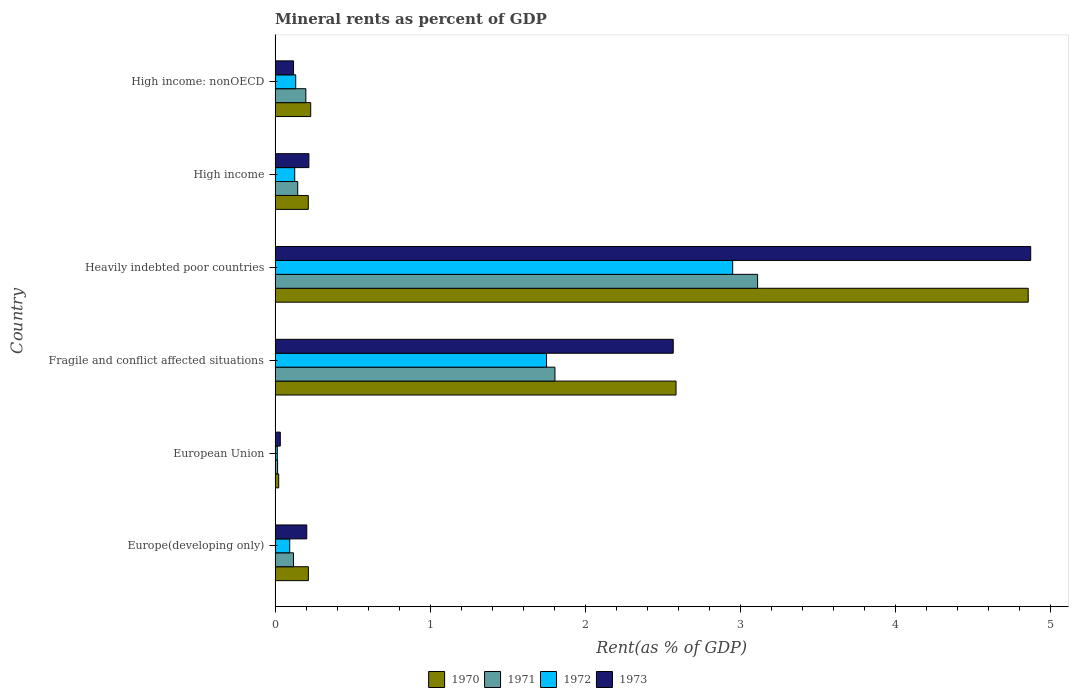How many different coloured bars are there?
Keep it short and to the point. 4. How many groups of bars are there?
Your answer should be compact. 6. Are the number of bars per tick equal to the number of legend labels?
Your response must be concise. Yes. How many bars are there on the 3rd tick from the bottom?
Make the answer very short. 4. What is the label of the 2nd group of bars from the top?
Your answer should be compact. High income. In how many cases, is the number of bars for a given country not equal to the number of legend labels?
Make the answer very short. 0. What is the mineral rent in 1972 in Europe(developing only)?
Your answer should be compact. 0.09. Across all countries, what is the maximum mineral rent in 1972?
Keep it short and to the point. 2.95. Across all countries, what is the minimum mineral rent in 1973?
Provide a succinct answer. 0.03. In which country was the mineral rent in 1972 maximum?
Ensure brevity in your answer.  Heavily indebted poor countries. What is the total mineral rent in 1972 in the graph?
Provide a short and direct response. 5.07. What is the difference between the mineral rent in 1971 in Europe(developing only) and that in Fragile and conflict affected situations?
Your answer should be very brief. -1.69. What is the difference between the mineral rent in 1970 in High income and the mineral rent in 1973 in High income: nonOECD?
Provide a short and direct response. 0.1. What is the average mineral rent in 1971 per country?
Your answer should be very brief. 0.9. What is the difference between the mineral rent in 1973 and mineral rent in 1971 in Heavily indebted poor countries?
Provide a short and direct response. 1.76. What is the ratio of the mineral rent in 1973 in Europe(developing only) to that in European Union?
Offer a terse response. 6.06. What is the difference between the highest and the second highest mineral rent in 1970?
Your answer should be compact. 2.27. What is the difference between the highest and the lowest mineral rent in 1972?
Offer a very short reply. 2.94. Is it the case that in every country, the sum of the mineral rent in 1971 and mineral rent in 1970 is greater than the sum of mineral rent in 1973 and mineral rent in 1972?
Ensure brevity in your answer.  No. How many countries are there in the graph?
Keep it short and to the point. 6. What is the difference between two consecutive major ticks on the X-axis?
Your answer should be very brief. 1. Are the values on the major ticks of X-axis written in scientific E-notation?
Offer a terse response. No. How many legend labels are there?
Keep it short and to the point. 4. What is the title of the graph?
Give a very brief answer. Mineral rents as percent of GDP. What is the label or title of the X-axis?
Keep it short and to the point. Rent(as % of GDP). What is the Rent(as % of GDP) of 1970 in Europe(developing only)?
Provide a short and direct response. 0.21. What is the Rent(as % of GDP) in 1971 in Europe(developing only)?
Your response must be concise. 0.12. What is the Rent(as % of GDP) in 1972 in Europe(developing only)?
Keep it short and to the point. 0.09. What is the Rent(as % of GDP) of 1973 in Europe(developing only)?
Your response must be concise. 0.2. What is the Rent(as % of GDP) in 1970 in European Union?
Your answer should be compact. 0.02. What is the Rent(as % of GDP) in 1971 in European Union?
Your response must be concise. 0.02. What is the Rent(as % of GDP) in 1972 in European Union?
Ensure brevity in your answer.  0.01. What is the Rent(as % of GDP) in 1973 in European Union?
Your answer should be very brief. 0.03. What is the Rent(as % of GDP) of 1970 in Fragile and conflict affected situations?
Your answer should be compact. 2.59. What is the Rent(as % of GDP) in 1971 in Fragile and conflict affected situations?
Keep it short and to the point. 1.81. What is the Rent(as % of GDP) in 1972 in Fragile and conflict affected situations?
Your response must be concise. 1.75. What is the Rent(as % of GDP) in 1973 in Fragile and conflict affected situations?
Ensure brevity in your answer.  2.57. What is the Rent(as % of GDP) of 1970 in Heavily indebted poor countries?
Offer a very short reply. 4.86. What is the Rent(as % of GDP) in 1971 in Heavily indebted poor countries?
Make the answer very short. 3.11. What is the Rent(as % of GDP) in 1972 in Heavily indebted poor countries?
Keep it short and to the point. 2.95. What is the Rent(as % of GDP) in 1973 in Heavily indebted poor countries?
Keep it short and to the point. 4.87. What is the Rent(as % of GDP) of 1970 in High income?
Make the answer very short. 0.21. What is the Rent(as % of GDP) of 1971 in High income?
Offer a terse response. 0.15. What is the Rent(as % of GDP) in 1972 in High income?
Your response must be concise. 0.13. What is the Rent(as % of GDP) in 1973 in High income?
Offer a terse response. 0.22. What is the Rent(as % of GDP) in 1970 in High income: nonOECD?
Provide a short and direct response. 0.23. What is the Rent(as % of GDP) of 1971 in High income: nonOECD?
Provide a succinct answer. 0.2. What is the Rent(as % of GDP) of 1972 in High income: nonOECD?
Your response must be concise. 0.13. What is the Rent(as % of GDP) in 1973 in High income: nonOECD?
Offer a very short reply. 0.12. Across all countries, what is the maximum Rent(as % of GDP) of 1970?
Offer a terse response. 4.86. Across all countries, what is the maximum Rent(as % of GDP) of 1971?
Give a very brief answer. 3.11. Across all countries, what is the maximum Rent(as % of GDP) in 1972?
Make the answer very short. 2.95. Across all countries, what is the maximum Rent(as % of GDP) of 1973?
Provide a short and direct response. 4.87. Across all countries, what is the minimum Rent(as % of GDP) of 1970?
Offer a very short reply. 0.02. Across all countries, what is the minimum Rent(as % of GDP) in 1971?
Your answer should be compact. 0.02. Across all countries, what is the minimum Rent(as % of GDP) in 1972?
Offer a very short reply. 0.01. Across all countries, what is the minimum Rent(as % of GDP) of 1973?
Ensure brevity in your answer.  0.03. What is the total Rent(as % of GDP) of 1970 in the graph?
Provide a short and direct response. 8.13. What is the total Rent(as % of GDP) in 1971 in the graph?
Provide a short and direct response. 5.4. What is the total Rent(as % of GDP) in 1972 in the graph?
Your response must be concise. 5.07. What is the total Rent(as % of GDP) in 1973 in the graph?
Your response must be concise. 8.02. What is the difference between the Rent(as % of GDP) of 1970 in Europe(developing only) and that in European Union?
Offer a very short reply. 0.19. What is the difference between the Rent(as % of GDP) in 1971 in Europe(developing only) and that in European Union?
Provide a succinct answer. 0.1. What is the difference between the Rent(as % of GDP) of 1972 in Europe(developing only) and that in European Union?
Your answer should be very brief. 0.08. What is the difference between the Rent(as % of GDP) of 1973 in Europe(developing only) and that in European Union?
Offer a very short reply. 0.17. What is the difference between the Rent(as % of GDP) in 1970 in Europe(developing only) and that in Fragile and conflict affected situations?
Make the answer very short. -2.37. What is the difference between the Rent(as % of GDP) of 1971 in Europe(developing only) and that in Fragile and conflict affected situations?
Your answer should be compact. -1.69. What is the difference between the Rent(as % of GDP) of 1972 in Europe(developing only) and that in Fragile and conflict affected situations?
Make the answer very short. -1.66. What is the difference between the Rent(as % of GDP) in 1973 in Europe(developing only) and that in Fragile and conflict affected situations?
Offer a terse response. -2.36. What is the difference between the Rent(as % of GDP) in 1970 in Europe(developing only) and that in Heavily indebted poor countries?
Your response must be concise. -4.64. What is the difference between the Rent(as % of GDP) in 1971 in Europe(developing only) and that in Heavily indebted poor countries?
Offer a very short reply. -2.99. What is the difference between the Rent(as % of GDP) of 1972 in Europe(developing only) and that in Heavily indebted poor countries?
Make the answer very short. -2.86. What is the difference between the Rent(as % of GDP) of 1973 in Europe(developing only) and that in Heavily indebted poor countries?
Provide a succinct answer. -4.67. What is the difference between the Rent(as % of GDP) in 1970 in Europe(developing only) and that in High income?
Your answer should be very brief. 0. What is the difference between the Rent(as % of GDP) in 1971 in Europe(developing only) and that in High income?
Offer a very short reply. -0.03. What is the difference between the Rent(as % of GDP) in 1972 in Europe(developing only) and that in High income?
Your answer should be compact. -0.03. What is the difference between the Rent(as % of GDP) of 1973 in Europe(developing only) and that in High income?
Your answer should be very brief. -0.01. What is the difference between the Rent(as % of GDP) in 1970 in Europe(developing only) and that in High income: nonOECD?
Ensure brevity in your answer.  -0.01. What is the difference between the Rent(as % of GDP) of 1971 in Europe(developing only) and that in High income: nonOECD?
Keep it short and to the point. -0.08. What is the difference between the Rent(as % of GDP) of 1972 in Europe(developing only) and that in High income: nonOECD?
Offer a very short reply. -0.04. What is the difference between the Rent(as % of GDP) of 1973 in Europe(developing only) and that in High income: nonOECD?
Your answer should be very brief. 0.09. What is the difference between the Rent(as % of GDP) of 1970 in European Union and that in Fragile and conflict affected situations?
Your response must be concise. -2.56. What is the difference between the Rent(as % of GDP) in 1971 in European Union and that in Fragile and conflict affected situations?
Your response must be concise. -1.79. What is the difference between the Rent(as % of GDP) in 1972 in European Union and that in Fragile and conflict affected situations?
Ensure brevity in your answer.  -1.74. What is the difference between the Rent(as % of GDP) in 1973 in European Union and that in Fragile and conflict affected situations?
Your response must be concise. -2.53. What is the difference between the Rent(as % of GDP) of 1970 in European Union and that in Heavily indebted poor countries?
Provide a short and direct response. -4.83. What is the difference between the Rent(as % of GDP) in 1971 in European Union and that in Heavily indebted poor countries?
Your answer should be very brief. -3.1. What is the difference between the Rent(as % of GDP) in 1972 in European Union and that in Heavily indebted poor countries?
Your answer should be very brief. -2.94. What is the difference between the Rent(as % of GDP) of 1973 in European Union and that in Heavily indebted poor countries?
Offer a terse response. -4.84. What is the difference between the Rent(as % of GDP) in 1970 in European Union and that in High income?
Your response must be concise. -0.19. What is the difference between the Rent(as % of GDP) in 1971 in European Union and that in High income?
Make the answer very short. -0.13. What is the difference between the Rent(as % of GDP) of 1972 in European Union and that in High income?
Provide a succinct answer. -0.11. What is the difference between the Rent(as % of GDP) of 1973 in European Union and that in High income?
Provide a succinct answer. -0.18. What is the difference between the Rent(as % of GDP) in 1970 in European Union and that in High income: nonOECD?
Make the answer very short. -0.21. What is the difference between the Rent(as % of GDP) of 1971 in European Union and that in High income: nonOECD?
Your answer should be compact. -0.18. What is the difference between the Rent(as % of GDP) in 1972 in European Union and that in High income: nonOECD?
Your answer should be very brief. -0.12. What is the difference between the Rent(as % of GDP) in 1973 in European Union and that in High income: nonOECD?
Your answer should be compact. -0.09. What is the difference between the Rent(as % of GDP) in 1970 in Fragile and conflict affected situations and that in Heavily indebted poor countries?
Give a very brief answer. -2.27. What is the difference between the Rent(as % of GDP) in 1971 in Fragile and conflict affected situations and that in Heavily indebted poor countries?
Provide a short and direct response. -1.31. What is the difference between the Rent(as % of GDP) of 1972 in Fragile and conflict affected situations and that in Heavily indebted poor countries?
Offer a terse response. -1.2. What is the difference between the Rent(as % of GDP) in 1973 in Fragile and conflict affected situations and that in Heavily indebted poor countries?
Your answer should be very brief. -2.31. What is the difference between the Rent(as % of GDP) of 1970 in Fragile and conflict affected situations and that in High income?
Provide a succinct answer. 2.37. What is the difference between the Rent(as % of GDP) of 1971 in Fragile and conflict affected situations and that in High income?
Offer a terse response. 1.66. What is the difference between the Rent(as % of GDP) in 1972 in Fragile and conflict affected situations and that in High income?
Offer a very short reply. 1.62. What is the difference between the Rent(as % of GDP) in 1973 in Fragile and conflict affected situations and that in High income?
Offer a terse response. 2.35. What is the difference between the Rent(as % of GDP) in 1970 in Fragile and conflict affected situations and that in High income: nonOECD?
Give a very brief answer. 2.36. What is the difference between the Rent(as % of GDP) in 1971 in Fragile and conflict affected situations and that in High income: nonOECD?
Your answer should be very brief. 1.61. What is the difference between the Rent(as % of GDP) of 1972 in Fragile and conflict affected situations and that in High income: nonOECD?
Provide a succinct answer. 1.62. What is the difference between the Rent(as % of GDP) in 1973 in Fragile and conflict affected situations and that in High income: nonOECD?
Ensure brevity in your answer.  2.45. What is the difference between the Rent(as % of GDP) in 1970 in Heavily indebted poor countries and that in High income?
Keep it short and to the point. 4.64. What is the difference between the Rent(as % of GDP) in 1971 in Heavily indebted poor countries and that in High income?
Make the answer very short. 2.97. What is the difference between the Rent(as % of GDP) in 1972 in Heavily indebted poor countries and that in High income?
Provide a short and direct response. 2.82. What is the difference between the Rent(as % of GDP) of 1973 in Heavily indebted poor countries and that in High income?
Offer a terse response. 4.66. What is the difference between the Rent(as % of GDP) of 1970 in Heavily indebted poor countries and that in High income: nonOECD?
Your response must be concise. 4.63. What is the difference between the Rent(as % of GDP) of 1971 in Heavily indebted poor countries and that in High income: nonOECD?
Give a very brief answer. 2.91. What is the difference between the Rent(as % of GDP) of 1972 in Heavily indebted poor countries and that in High income: nonOECD?
Give a very brief answer. 2.82. What is the difference between the Rent(as % of GDP) of 1973 in Heavily indebted poor countries and that in High income: nonOECD?
Offer a terse response. 4.75. What is the difference between the Rent(as % of GDP) in 1970 in High income and that in High income: nonOECD?
Your response must be concise. -0.02. What is the difference between the Rent(as % of GDP) of 1971 in High income and that in High income: nonOECD?
Keep it short and to the point. -0.05. What is the difference between the Rent(as % of GDP) of 1972 in High income and that in High income: nonOECD?
Your response must be concise. -0.01. What is the difference between the Rent(as % of GDP) in 1973 in High income and that in High income: nonOECD?
Offer a very short reply. 0.1. What is the difference between the Rent(as % of GDP) of 1970 in Europe(developing only) and the Rent(as % of GDP) of 1971 in European Union?
Provide a short and direct response. 0.2. What is the difference between the Rent(as % of GDP) in 1970 in Europe(developing only) and the Rent(as % of GDP) in 1972 in European Union?
Offer a very short reply. 0.2. What is the difference between the Rent(as % of GDP) in 1970 in Europe(developing only) and the Rent(as % of GDP) in 1973 in European Union?
Your answer should be compact. 0.18. What is the difference between the Rent(as % of GDP) of 1971 in Europe(developing only) and the Rent(as % of GDP) of 1972 in European Union?
Offer a very short reply. 0.1. What is the difference between the Rent(as % of GDP) of 1971 in Europe(developing only) and the Rent(as % of GDP) of 1973 in European Union?
Give a very brief answer. 0.09. What is the difference between the Rent(as % of GDP) of 1972 in Europe(developing only) and the Rent(as % of GDP) of 1973 in European Union?
Your answer should be compact. 0.06. What is the difference between the Rent(as % of GDP) of 1970 in Europe(developing only) and the Rent(as % of GDP) of 1971 in Fragile and conflict affected situations?
Offer a very short reply. -1.59. What is the difference between the Rent(as % of GDP) in 1970 in Europe(developing only) and the Rent(as % of GDP) in 1972 in Fragile and conflict affected situations?
Your answer should be very brief. -1.54. What is the difference between the Rent(as % of GDP) in 1970 in Europe(developing only) and the Rent(as % of GDP) in 1973 in Fragile and conflict affected situations?
Your answer should be very brief. -2.35. What is the difference between the Rent(as % of GDP) of 1971 in Europe(developing only) and the Rent(as % of GDP) of 1972 in Fragile and conflict affected situations?
Offer a very short reply. -1.63. What is the difference between the Rent(as % of GDP) of 1971 in Europe(developing only) and the Rent(as % of GDP) of 1973 in Fragile and conflict affected situations?
Give a very brief answer. -2.45. What is the difference between the Rent(as % of GDP) of 1972 in Europe(developing only) and the Rent(as % of GDP) of 1973 in Fragile and conflict affected situations?
Keep it short and to the point. -2.47. What is the difference between the Rent(as % of GDP) of 1970 in Europe(developing only) and the Rent(as % of GDP) of 1971 in Heavily indebted poor countries?
Provide a short and direct response. -2.9. What is the difference between the Rent(as % of GDP) in 1970 in Europe(developing only) and the Rent(as % of GDP) in 1972 in Heavily indebted poor countries?
Provide a succinct answer. -2.74. What is the difference between the Rent(as % of GDP) in 1970 in Europe(developing only) and the Rent(as % of GDP) in 1973 in Heavily indebted poor countries?
Give a very brief answer. -4.66. What is the difference between the Rent(as % of GDP) of 1971 in Europe(developing only) and the Rent(as % of GDP) of 1972 in Heavily indebted poor countries?
Your answer should be very brief. -2.83. What is the difference between the Rent(as % of GDP) in 1971 in Europe(developing only) and the Rent(as % of GDP) in 1973 in Heavily indebted poor countries?
Your response must be concise. -4.76. What is the difference between the Rent(as % of GDP) of 1972 in Europe(developing only) and the Rent(as % of GDP) of 1973 in Heavily indebted poor countries?
Give a very brief answer. -4.78. What is the difference between the Rent(as % of GDP) of 1970 in Europe(developing only) and the Rent(as % of GDP) of 1971 in High income?
Provide a short and direct response. 0.07. What is the difference between the Rent(as % of GDP) of 1970 in Europe(developing only) and the Rent(as % of GDP) of 1972 in High income?
Your answer should be compact. 0.09. What is the difference between the Rent(as % of GDP) in 1970 in Europe(developing only) and the Rent(as % of GDP) in 1973 in High income?
Your answer should be very brief. -0. What is the difference between the Rent(as % of GDP) of 1971 in Europe(developing only) and the Rent(as % of GDP) of 1972 in High income?
Offer a terse response. -0.01. What is the difference between the Rent(as % of GDP) of 1971 in Europe(developing only) and the Rent(as % of GDP) of 1973 in High income?
Offer a terse response. -0.1. What is the difference between the Rent(as % of GDP) of 1972 in Europe(developing only) and the Rent(as % of GDP) of 1973 in High income?
Offer a very short reply. -0.12. What is the difference between the Rent(as % of GDP) of 1970 in Europe(developing only) and the Rent(as % of GDP) of 1971 in High income: nonOECD?
Make the answer very short. 0.02. What is the difference between the Rent(as % of GDP) in 1970 in Europe(developing only) and the Rent(as % of GDP) in 1972 in High income: nonOECD?
Provide a short and direct response. 0.08. What is the difference between the Rent(as % of GDP) of 1970 in Europe(developing only) and the Rent(as % of GDP) of 1973 in High income: nonOECD?
Your response must be concise. 0.1. What is the difference between the Rent(as % of GDP) in 1971 in Europe(developing only) and the Rent(as % of GDP) in 1972 in High income: nonOECD?
Offer a very short reply. -0.01. What is the difference between the Rent(as % of GDP) of 1971 in Europe(developing only) and the Rent(as % of GDP) of 1973 in High income: nonOECD?
Ensure brevity in your answer.  -0. What is the difference between the Rent(as % of GDP) of 1972 in Europe(developing only) and the Rent(as % of GDP) of 1973 in High income: nonOECD?
Make the answer very short. -0.02. What is the difference between the Rent(as % of GDP) of 1970 in European Union and the Rent(as % of GDP) of 1971 in Fragile and conflict affected situations?
Your answer should be very brief. -1.78. What is the difference between the Rent(as % of GDP) of 1970 in European Union and the Rent(as % of GDP) of 1972 in Fragile and conflict affected situations?
Your answer should be very brief. -1.73. What is the difference between the Rent(as % of GDP) of 1970 in European Union and the Rent(as % of GDP) of 1973 in Fragile and conflict affected situations?
Ensure brevity in your answer.  -2.54. What is the difference between the Rent(as % of GDP) of 1971 in European Union and the Rent(as % of GDP) of 1972 in Fragile and conflict affected situations?
Make the answer very short. -1.73. What is the difference between the Rent(as % of GDP) of 1971 in European Union and the Rent(as % of GDP) of 1973 in Fragile and conflict affected situations?
Ensure brevity in your answer.  -2.55. What is the difference between the Rent(as % of GDP) of 1972 in European Union and the Rent(as % of GDP) of 1973 in Fragile and conflict affected situations?
Keep it short and to the point. -2.55. What is the difference between the Rent(as % of GDP) in 1970 in European Union and the Rent(as % of GDP) in 1971 in Heavily indebted poor countries?
Offer a terse response. -3.09. What is the difference between the Rent(as % of GDP) in 1970 in European Union and the Rent(as % of GDP) in 1972 in Heavily indebted poor countries?
Provide a succinct answer. -2.93. What is the difference between the Rent(as % of GDP) in 1970 in European Union and the Rent(as % of GDP) in 1973 in Heavily indebted poor countries?
Your answer should be compact. -4.85. What is the difference between the Rent(as % of GDP) in 1971 in European Union and the Rent(as % of GDP) in 1972 in Heavily indebted poor countries?
Your answer should be very brief. -2.94. What is the difference between the Rent(as % of GDP) of 1971 in European Union and the Rent(as % of GDP) of 1973 in Heavily indebted poor countries?
Your answer should be very brief. -4.86. What is the difference between the Rent(as % of GDP) in 1972 in European Union and the Rent(as % of GDP) in 1973 in Heavily indebted poor countries?
Make the answer very short. -4.86. What is the difference between the Rent(as % of GDP) of 1970 in European Union and the Rent(as % of GDP) of 1971 in High income?
Provide a short and direct response. -0.12. What is the difference between the Rent(as % of GDP) of 1970 in European Union and the Rent(as % of GDP) of 1972 in High income?
Your response must be concise. -0.1. What is the difference between the Rent(as % of GDP) of 1970 in European Union and the Rent(as % of GDP) of 1973 in High income?
Keep it short and to the point. -0.19. What is the difference between the Rent(as % of GDP) of 1971 in European Union and the Rent(as % of GDP) of 1972 in High income?
Ensure brevity in your answer.  -0.11. What is the difference between the Rent(as % of GDP) of 1971 in European Union and the Rent(as % of GDP) of 1973 in High income?
Your response must be concise. -0.2. What is the difference between the Rent(as % of GDP) of 1972 in European Union and the Rent(as % of GDP) of 1973 in High income?
Your answer should be very brief. -0.2. What is the difference between the Rent(as % of GDP) in 1970 in European Union and the Rent(as % of GDP) in 1971 in High income: nonOECD?
Make the answer very short. -0.18. What is the difference between the Rent(as % of GDP) in 1970 in European Union and the Rent(as % of GDP) in 1972 in High income: nonOECD?
Your answer should be very brief. -0.11. What is the difference between the Rent(as % of GDP) in 1970 in European Union and the Rent(as % of GDP) in 1973 in High income: nonOECD?
Your answer should be compact. -0.1. What is the difference between the Rent(as % of GDP) in 1971 in European Union and the Rent(as % of GDP) in 1972 in High income: nonOECD?
Offer a terse response. -0.12. What is the difference between the Rent(as % of GDP) in 1971 in European Union and the Rent(as % of GDP) in 1973 in High income: nonOECD?
Offer a terse response. -0.1. What is the difference between the Rent(as % of GDP) in 1972 in European Union and the Rent(as % of GDP) in 1973 in High income: nonOECD?
Your answer should be compact. -0.1. What is the difference between the Rent(as % of GDP) in 1970 in Fragile and conflict affected situations and the Rent(as % of GDP) in 1971 in Heavily indebted poor countries?
Give a very brief answer. -0.53. What is the difference between the Rent(as % of GDP) of 1970 in Fragile and conflict affected situations and the Rent(as % of GDP) of 1972 in Heavily indebted poor countries?
Provide a short and direct response. -0.37. What is the difference between the Rent(as % of GDP) of 1970 in Fragile and conflict affected situations and the Rent(as % of GDP) of 1973 in Heavily indebted poor countries?
Provide a short and direct response. -2.29. What is the difference between the Rent(as % of GDP) of 1971 in Fragile and conflict affected situations and the Rent(as % of GDP) of 1972 in Heavily indebted poor countries?
Keep it short and to the point. -1.15. What is the difference between the Rent(as % of GDP) in 1971 in Fragile and conflict affected situations and the Rent(as % of GDP) in 1973 in Heavily indebted poor countries?
Provide a short and direct response. -3.07. What is the difference between the Rent(as % of GDP) in 1972 in Fragile and conflict affected situations and the Rent(as % of GDP) in 1973 in Heavily indebted poor countries?
Make the answer very short. -3.12. What is the difference between the Rent(as % of GDP) of 1970 in Fragile and conflict affected situations and the Rent(as % of GDP) of 1971 in High income?
Your response must be concise. 2.44. What is the difference between the Rent(as % of GDP) of 1970 in Fragile and conflict affected situations and the Rent(as % of GDP) of 1972 in High income?
Offer a terse response. 2.46. What is the difference between the Rent(as % of GDP) of 1970 in Fragile and conflict affected situations and the Rent(as % of GDP) of 1973 in High income?
Offer a terse response. 2.37. What is the difference between the Rent(as % of GDP) in 1971 in Fragile and conflict affected situations and the Rent(as % of GDP) in 1972 in High income?
Your response must be concise. 1.68. What is the difference between the Rent(as % of GDP) of 1971 in Fragile and conflict affected situations and the Rent(as % of GDP) of 1973 in High income?
Your response must be concise. 1.59. What is the difference between the Rent(as % of GDP) of 1972 in Fragile and conflict affected situations and the Rent(as % of GDP) of 1973 in High income?
Make the answer very short. 1.53. What is the difference between the Rent(as % of GDP) in 1970 in Fragile and conflict affected situations and the Rent(as % of GDP) in 1971 in High income: nonOECD?
Keep it short and to the point. 2.39. What is the difference between the Rent(as % of GDP) in 1970 in Fragile and conflict affected situations and the Rent(as % of GDP) in 1972 in High income: nonOECD?
Offer a terse response. 2.45. What is the difference between the Rent(as % of GDP) of 1970 in Fragile and conflict affected situations and the Rent(as % of GDP) of 1973 in High income: nonOECD?
Your answer should be compact. 2.47. What is the difference between the Rent(as % of GDP) of 1971 in Fragile and conflict affected situations and the Rent(as % of GDP) of 1972 in High income: nonOECD?
Make the answer very short. 1.67. What is the difference between the Rent(as % of GDP) of 1971 in Fragile and conflict affected situations and the Rent(as % of GDP) of 1973 in High income: nonOECD?
Offer a very short reply. 1.69. What is the difference between the Rent(as % of GDP) in 1972 in Fragile and conflict affected situations and the Rent(as % of GDP) in 1973 in High income: nonOECD?
Offer a very short reply. 1.63. What is the difference between the Rent(as % of GDP) of 1970 in Heavily indebted poor countries and the Rent(as % of GDP) of 1971 in High income?
Give a very brief answer. 4.71. What is the difference between the Rent(as % of GDP) of 1970 in Heavily indebted poor countries and the Rent(as % of GDP) of 1972 in High income?
Provide a succinct answer. 4.73. What is the difference between the Rent(as % of GDP) of 1970 in Heavily indebted poor countries and the Rent(as % of GDP) of 1973 in High income?
Ensure brevity in your answer.  4.64. What is the difference between the Rent(as % of GDP) of 1971 in Heavily indebted poor countries and the Rent(as % of GDP) of 1972 in High income?
Keep it short and to the point. 2.99. What is the difference between the Rent(as % of GDP) of 1971 in Heavily indebted poor countries and the Rent(as % of GDP) of 1973 in High income?
Make the answer very short. 2.89. What is the difference between the Rent(as % of GDP) in 1972 in Heavily indebted poor countries and the Rent(as % of GDP) in 1973 in High income?
Your answer should be very brief. 2.73. What is the difference between the Rent(as % of GDP) of 1970 in Heavily indebted poor countries and the Rent(as % of GDP) of 1971 in High income: nonOECD?
Ensure brevity in your answer.  4.66. What is the difference between the Rent(as % of GDP) in 1970 in Heavily indebted poor countries and the Rent(as % of GDP) in 1972 in High income: nonOECD?
Give a very brief answer. 4.72. What is the difference between the Rent(as % of GDP) of 1970 in Heavily indebted poor countries and the Rent(as % of GDP) of 1973 in High income: nonOECD?
Provide a succinct answer. 4.74. What is the difference between the Rent(as % of GDP) in 1971 in Heavily indebted poor countries and the Rent(as % of GDP) in 1972 in High income: nonOECD?
Make the answer very short. 2.98. What is the difference between the Rent(as % of GDP) of 1971 in Heavily indebted poor countries and the Rent(as % of GDP) of 1973 in High income: nonOECD?
Ensure brevity in your answer.  2.99. What is the difference between the Rent(as % of GDP) of 1972 in Heavily indebted poor countries and the Rent(as % of GDP) of 1973 in High income: nonOECD?
Offer a terse response. 2.83. What is the difference between the Rent(as % of GDP) of 1970 in High income and the Rent(as % of GDP) of 1971 in High income: nonOECD?
Offer a very short reply. 0.02. What is the difference between the Rent(as % of GDP) in 1970 in High income and the Rent(as % of GDP) in 1972 in High income: nonOECD?
Offer a terse response. 0.08. What is the difference between the Rent(as % of GDP) in 1970 in High income and the Rent(as % of GDP) in 1973 in High income: nonOECD?
Your answer should be very brief. 0.1. What is the difference between the Rent(as % of GDP) in 1971 in High income and the Rent(as % of GDP) in 1972 in High income: nonOECD?
Provide a short and direct response. 0.01. What is the difference between the Rent(as % of GDP) of 1971 in High income and the Rent(as % of GDP) of 1973 in High income: nonOECD?
Offer a terse response. 0.03. What is the difference between the Rent(as % of GDP) of 1972 in High income and the Rent(as % of GDP) of 1973 in High income: nonOECD?
Make the answer very short. 0.01. What is the average Rent(as % of GDP) of 1970 per country?
Your response must be concise. 1.35. What is the average Rent(as % of GDP) in 1971 per country?
Your answer should be compact. 0.9. What is the average Rent(as % of GDP) in 1972 per country?
Make the answer very short. 0.85. What is the average Rent(as % of GDP) of 1973 per country?
Your answer should be very brief. 1.34. What is the difference between the Rent(as % of GDP) in 1970 and Rent(as % of GDP) in 1971 in Europe(developing only)?
Offer a very short reply. 0.1. What is the difference between the Rent(as % of GDP) in 1970 and Rent(as % of GDP) in 1972 in Europe(developing only)?
Provide a short and direct response. 0.12. What is the difference between the Rent(as % of GDP) in 1970 and Rent(as % of GDP) in 1973 in Europe(developing only)?
Your response must be concise. 0.01. What is the difference between the Rent(as % of GDP) of 1971 and Rent(as % of GDP) of 1972 in Europe(developing only)?
Offer a terse response. 0.02. What is the difference between the Rent(as % of GDP) of 1971 and Rent(as % of GDP) of 1973 in Europe(developing only)?
Keep it short and to the point. -0.09. What is the difference between the Rent(as % of GDP) of 1972 and Rent(as % of GDP) of 1973 in Europe(developing only)?
Offer a very short reply. -0.11. What is the difference between the Rent(as % of GDP) of 1970 and Rent(as % of GDP) of 1971 in European Union?
Make the answer very short. 0.01. What is the difference between the Rent(as % of GDP) of 1970 and Rent(as % of GDP) of 1972 in European Union?
Your response must be concise. 0.01. What is the difference between the Rent(as % of GDP) of 1970 and Rent(as % of GDP) of 1973 in European Union?
Make the answer very short. -0.01. What is the difference between the Rent(as % of GDP) in 1971 and Rent(as % of GDP) in 1972 in European Union?
Provide a short and direct response. 0. What is the difference between the Rent(as % of GDP) in 1971 and Rent(as % of GDP) in 1973 in European Union?
Offer a very short reply. -0.02. What is the difference between the Rent(as % of GDP) of 1972 and Rent(as % of GDP) of 1973 in European Union?
Your response must be concise. -0.02. What is the difference between the Rent(as % of GDP) in 1970 and Rent(as % of GDP) in 1971 in Fragile and conflict affected situations?
Keep it short and to the point. 0.78. What is the difference between the Rent(as % of GDP) in 1970 and Rent(as % of GDP) in 1972 in Fragile and conflict affected situations?
Keep it short and to the point. 0.84. What is the difference between the Rent(as % of GDP) in 1970 and Rent(as % of GDP) in 1973 in Fragile and conflict affected situations?
Provide a short and direct response. 0.02. What is the difference between the Rent(as % of GDP) of 1971 and Rent(as % of GDP) of 1972 in Fragile and conflict affected situations?
Give a very brief answer. 0.05. What is the difference between the Rent(as % of GDP) of 1971 and Rent(as % of GDP) of 1973 in Fragile and conflict affected situations?
Offer a terse response. -0.76. What is the difference between the Rent(as % of GDP) of 1972 and Rent(as % of GDP) of 1973 in Fragile and conflict affected situations?
Provide a succinct answer. -0.82. What is the difference between the Rent(as % of GDP) of 1970 and Rent(as % of GDP) of 1971 in Heavily indebted poor countries?
Give a very brief answer. 1.75. What is the difference between the Rent(as % of GDP) of 1970 and Rent(as % of GDP) of 1972 in Heavily indebted poor countries?
Give a very brief answer. 1.91. What is the difference between the Rent(as % of GDP) of 1970 and Rent(as % of GDP) of 1973 in Heavily indebted poor countries?
Your answer should be compact. -0.02. What is the difference between the Rent(as % of GDP) in 1971 and Rent(as % of GDP) in 1972 in Heavily indebted poor countries?
Make the answer very short. 0.16. What is the difference between the Rent(as % of GDP) in 1971 and Rent(as % of GDP) in 1973 in Heavily indebted poor countries?
Keep it short and to the point. -1.76. What is the difference between the Rent(as % of GDP) in 1972 and Rent(as % of GDP) in 1973 in Heavily indebted poor countries?
Make the answer very short. -1.92. What is the difference between the Rent(as % of GDP) of 1970 and Rent(as % of GDP) of 1971 in High income?
Provide a short and direct response. 0.07. What is the difference between the Rent(as % of GDP) in 1970 and Rent(as % of GDP) in 1972 in High income?
Ensure brevity in your answer.  0.09. What is the difference between the Rent(as % of GDP) of 1970 and Rent(as % of GDP) of 1973 in High income?
Your answer should be compact. -0. What is the difference between the Rent(as % of GDP) of 1971 and Rent(as % of GDP) of 1972 in High income?
Your answer should be very brief. 0.02. What is the difference between the Rent(as % of GDP) in 1971 and Rent(as % of GDP) in 1973 in High income?
Keep it short and to the point. -0.07. What is the difference between the Rent(as % of GDP) of 1972 and Rent(as % of GDP) of 1973 in High income?
Provide a succinct answer. -0.09. What is the difference between the Rent(as % of GDP) in 1970 and Rent(as % of GDP) in 1971 in High income: nonOECD?
Keep it short and to the point. 0.03. What is the difference between the Rent(as % of GDP) in 1970 and Rent(as % of GDP) in 1972 in High income: nonOECD?
Your response must be concise. 0.1. What is the difference between the Rent(as % of GDP) in 1970 and Rent(as % of GDP) in 1973 in High income: nonOECD?
Provide a succinct answer. 0.11. What is the difference between the Rent(as % of GDP) in 1971 and Rent(as % of GDP) in 1972 in High income: nonOECD?
Offer a terse response. 0.07. What is the difference between the Rent(as % of GDP) of 1971 and Rent(as % of GDP) of 1973 in High income: nonOECD?
Give a very brief answer. 0.08. What is the difference between the Rent(as % of GDP) of 1972 and Rent(as % of GDP) of 1973 in High income: nonOECD?
Your answer should be compact. 0.01. What is the ratio of the Rent(as % of GDP) in 1970 in Europe(developing only) to that in European Union?
Your answer should be very brief. 9.2. What is the ratio of the Rent(as % of GDP) of 1971 in Europe(developing only) to that in European Union?
Your response must be concise. 7.31. What is the ratio of the Rent(as % of GDP) in 1972 in Europe(developing only) to that in European Union?
Offer a very short reply. 6.59. What is the ratio of the Rent(as % of GDP) of 1973 in Europe(developing only) to that in European Union?
Make the answer very short. 6.06. What is the ratio of the Rent(as % of GDP) of 1970 in Europe(developing only) to that in Fragile and conflict affected situations?
Offer a very short reply. 0.08. What is the ratio of the Rent(as % of GDP) in 1971 in Europe(developing only) to that in Fragile and conflict affected situations?
Offer a terse response. 0.07. What is the ratio of the Rent(as % of GDP) in 1972 in Europe(developing only) to that in Fragile and conflict affected situations?
Ensure brevity in your answer.  0.05. What is the ratio of the Rent(as % of GDP) in 1973 in Europe(developing only) to that in Fragile and conflict affected situations?
Offer a very short reply. 0.08. What is the ratio of the Rent(as % of GDP) of 1970 in Europe(developing only) to that in Heavily indebted poor countries?
Make the answer very short. 0.04. What is the ratio of the Rent(as % of GDP) of 1971 in Europe(developing only) to that in Heavily indebted poor countries?
Your response must be concise. 0.04. What is the ratio of the Rent(as % of GDP) in 1972 in Europe(developing only) to that in Heavily indebted poor countries?
Offer a very short reply. 0.03. What is the ratio of the Rent(as % of GDP) of 1973 in Europe(developing only) to that in Heavily indebted poor countries?
Keep it short and to the point. 0.04. What is the ratio of the Rent(as % of GDP) of 1971 in Europe(developing only) to that in High income?
Make the answer very short. 0.81. What is the ratio of the Rent(as % of GDP) in 1972 in Europe(developing only) to that in High income?
Your answer should be compact. 0.75. What is the ratio of the Rent(as % of GDP) in 1973 in Europe(developing only) to that in High income?
Offer a terse response. 0.94. What is the ratio of the Rent(as % of GDP) in 1970 in Europe(developing only) to that in High income: nonOECD?
Make the answer very short. 0.93. What is the ratio of the Rent(as % of GDP) of 1971 in Europe(developing only) to that in High income: nonOECD?
Make the answer very short. 0.6. What is the ratio of the Rent(as % of GDP) of 1972 in Europe(developing only) to that in High income: nonOECD?
Provide a short and direct response. 0.71. What is the ratio of the Rent(as % of GDP) of 1973 in Europe(developing only) to that in High income: nonOECD?
Give a very brief answer. 1.72. What is the ratio of the Rent(as % of GDP) of 1970 in European Union to that in Fragile and conflict affected situations?
Provide a succinct answer. 0.01. What is the ratio of the Rent(as % of GDP) in 1971 in European Union to that in Fragile and conflict affected situations?
Your answer should be very brief. 0.01. What is the ratio of the Rent(as % of GDP) in 1972 in European Union to that in Fragile and conflict affected situations?
Your answer should be compact. 0.01. What is the ratio of the Rent(as % of GDP) in 1973 in European Union to that in Fragile and conflict affected situations?
Your answer should be very brief. 0.01. What is the ratio of the Rent(as % of GDP) in 1970 in European Union to that in Heavily indebted poor countries?
Your answer should be compact. 0. What is the ratio of the Rent(as % of GDP) in 1971 in European Union to that in Heavily indebted poor countries?
Keep it short and to the point. 0.01. What is the ratio of the Rent(as % of GDP) in 1972 in European Union to that in Heavily indebted poor countries?
Offer a very short reply. 0. What is the ratio of the Rent(as % of GDP) of 1973 in European Union to that in Heavily indebted poor countries?
Make the answer very short. 0.01. What is the ratio of the Rent(as % of GDP) of 1970 in European Union to that in High income?
Your answer should be compact. 0.11. What is the ratio of the Rent(as % of GDP) of 1971 in European Union to that in High income?
Provide a short and direct response. 0.11. What is the ratio of the Rent(as % of GDP) of 1972 in European Union to that in High income?
Your response must be concise. 0.11. What is the ratio of the Rent(as % of GDP) in 1973 in European Union to that in High income?
Your response must be concise. 0.15. What is the ratio of the Rent(as % of GDP) of 1970 in European Union to that in High income: nonOECD?
Ensure brevity in your answer.  0.1. What is the ratio of the Rent(as % of GDP) in 1971 in European Union to that in High income: nonOECD?
Ensure brevity in your answer.  0.08. What is the ratio of the Rent(as % of GDP) of 1972 in European Union to that in High income: nonOECD?
Give a very brief answer. 0.11. What is the ratio of the Rent(as % of GDP) of 1973 in European Union to that in High income: nonOECD?
Offer a terse response. 0.28. What is the ratio of the Rent(as % of GDP) in 1970 in Fragile and conflict affected situations to that in Heavily indebted poor countries?
Your response must be concise. 0.53. What is the ratio of the Rent(as % of GDP) of 1971 in Fragile and conflict affected situations to that in Heavily indebted poor countries?
Provide a succinct answer. 0.58. What is the ratio of the Rent(as % of GDP) of 1972 in Fragile and conflict affected situations to that in Heavily indebted poor countries?
Provide a short and direct response. 0.59. What is the ratio of the Rent(as % of GDP) of 1973 in Fragile and conflict affected situations to that in Heavily indebted poor countries?
Ensure brevity in your answer.  0.53. What is the ratio of the Rent(as % of GDP) in 1970 in Fragile and conflict affected situations to that in High income?
Offer a very short reply. 12.08. What is the ratio of the Rent(as % of GDP) of 1971 in Fragile and conflict affected situations to that in High income?
Give a very brief answer. 12.36. What is the ratio of the Rent(as % of GDP) of 1972 in Fragile and conflict affected situations to that in High income?
Make the answer very short. 13.82. What is the ratio of the Rent(as % of GDP) of 1973 in Fragile and conflict affected situations to that in High income?
Provide a succinct answer. 11.78. What is the ratio of the Rent(as % of GDP) of 1970 in Fragile and conflict affected situations to that in High income: nonOECD?
Offer a terse response. 11.26. What is the ratio of the Rent(as % of GDP) of 1971 in Fragile and conflict affected situations to that in High income: nonOECD?
Provide a succinct answer. 9.09. What is the ratio of the Rent(as % of GDP) in 1972 in Fragile and conflict affected situations to that in High income: nonOECD?
Provide a succinct answer. 13.15. What is the ratio of the Rent(as % of GDP) in 1973 in Fragile and conflict affected situations to that in High income: nonOECD?
Your response must be concise. 21.58. What is the ratio of the Rent(as % of GDP) in 1970 in Heavily indebted poor countries to that in High income?
Your answer should be compact. 22.69. What is the ratio of the Rent(as % of GDP) in 1971 in Heavily indebted poor countries to that in High income?
Provide a short and direct response. 21.31. What is the ratio of the Rent(as % of GDP) in 1972 in Heavily indebted poor countries to that in High income?
Provide a succinct answer. 23.3. What is the ratio of the Rent(as % of GDP) in 1973 in Heavily indebted poor countries to that in High income?
Keep it short and to the point. 22.35. What is the ratio of the Rent(as % of GDP) in 1970 in Heavily indebted poor countries to that in High income: nonOECD?
Your answer should be very brief. 21.14. What is the ratio of the Rent(as % of GDP) of 1971 in Heavily indebted poor countries to that in High income: nonOECD?
Provide a short and direct response. 15.68. What is the ratio of the Rent(as % of GDP) in 1972 in Heavily indebted poor countries to that in High income: nonOECD?
Provide a succinct answer. 22.17. What is the ratio of the Rent(as % of GDP) of 1973 in Heavily indebted poor countries to that in High income: nonOECD?
Give a very brief answer. 40.95. What is the ratio of the Rent(as % of GDP) in 1970 in High income to that in High income: nonOECD?
Keep it short and to the point. 0.93. What is the ratio of the Rent(as % of GDP) of 1971 in High income to that in High income: nonOECD?
Your answer should be very brief. 0.74. What is the ratio of the Rent(as % of GDP) in 1972 in High income to that in High income: nonOECD?
Give a very brief answer. 0.95. What is the ratio of the Rent(as % of GDP) in 1973 in High income to that in High income: nonOECD?
Provide a succinct answer. 1.83. What is the difference between the highest and the second highest Rent(as % of GDP) in 1970?
Your answer should be very brief. 2.27. What is the difference between the highest and the second highest Rent(as % of GDP) in 1971?
Provide a short and direct response. 1.31. What is the difference between the highest and the second highest Rent(as % of GDP) of 1972?
Offer a very short reply. 1.2. What is the difference between the highest and the second highest Rent(as % of GDP) of 1973?
Your response must be concise. 2.31. What is the difference between the highest and the lowest Rent(as % of GDP) of 1970?
Your answer should be compact. 4.83. What is the difference between the highest and the lowest Rent(as % of GDP) of 1971?
Offer a terse response. 3.1. What is the difference between the highest and the lowest Rent(as % of GDP) of 1972?
Your answer should be very brief. 2.94. What is the difference between the highest and the lowest Rent(as % of GDP) of 1973?
Make the answer very short. 4.84. 